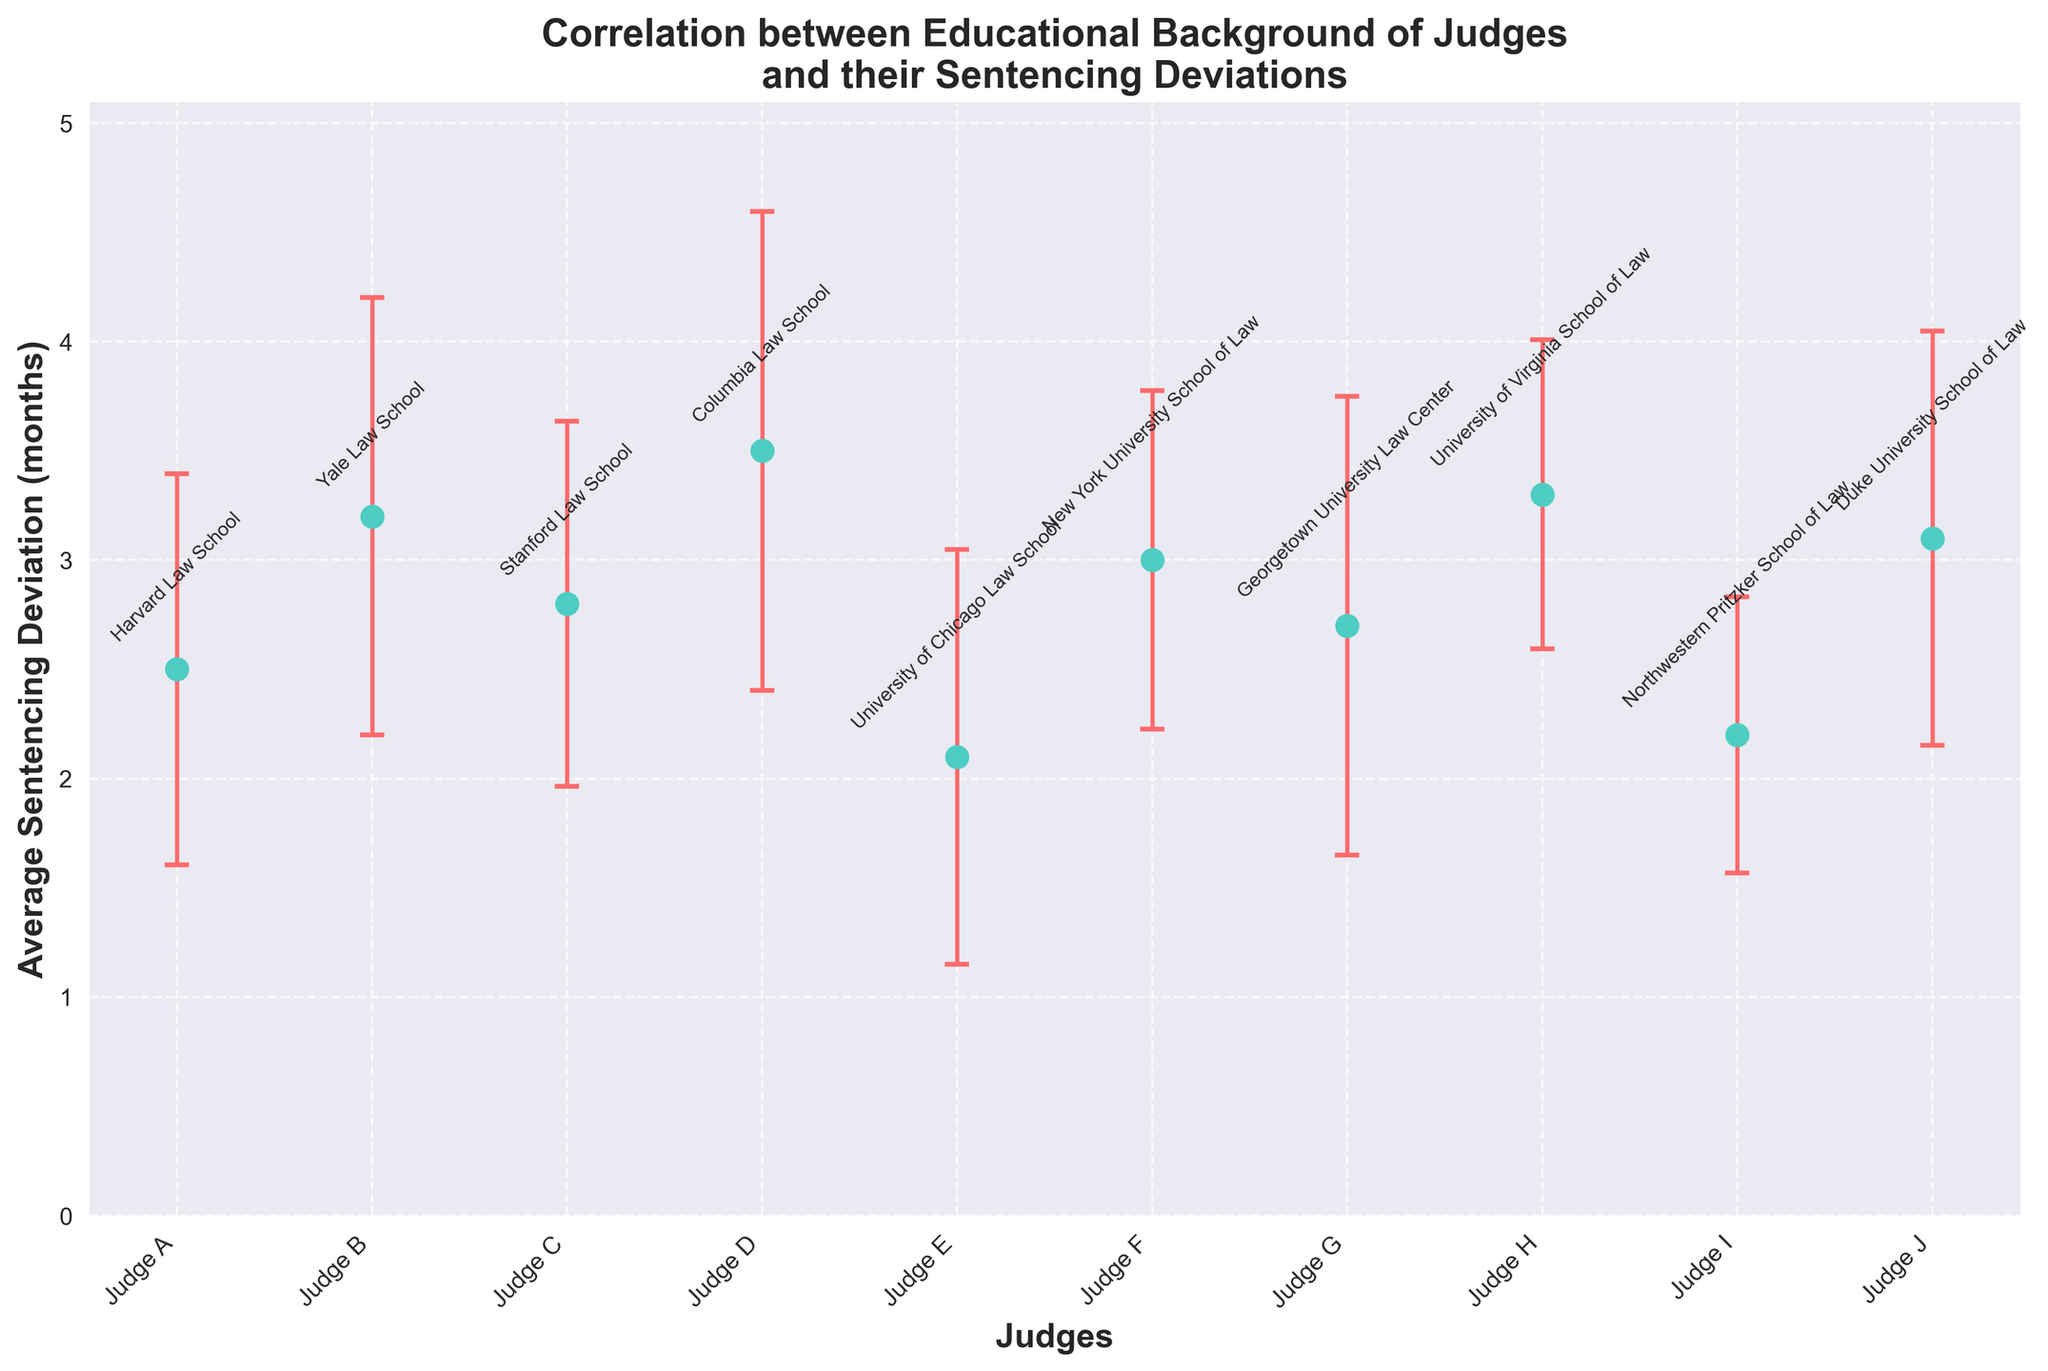What's the title of the figure? The title of the figure is written at the top of the plot, above the data points. It reads "Correlation between Educational Background of Judges and their Sentencing Deviations".
Answer: Correlation between Educational Background of Judges and their Sentencing Deviations How many judges are represented in the figure? The x-axis of the plot represents the judges. Counting the number of distinct data points gives us the total number of judges represented. There are 10 data points.
Answer: 10 Which judge has the highest average sentencing deviation? To find the highest average sentencing deviation, we look for the data point with the maximum y-value. Judge D from Columbia Law School has the highest value at 3.5 months.
Answer: Judge D What is the variance in sentencing deviations for Judge H? The error bars represent the variance, and we can also get this information from the data table. For Judge H from the University of Virginia School of Law, the variance value is 0.5.
Answer: 0.5 What is the approximate range of the average sentencing deviations represented in the figure? To find the range, we identify the lowest and highest y-values. The lowest is 2.1 (Judge E), and the highest is 3.5 (Judge D). Thus, the range is 3.5 - 2.1.
Answer: 1.4 Which two judges have the closest average sentencing deviations? To determine which two judges have the closest deviations, we compare the y-values. Judge C (2.8) and Judge G (2.7) have the closest deviations, with a difference of only 0.1 months.
Answer: Judge C and Judge G Which educational background corresponds to the judge with the smallest variance in sentencing deviations? We look for the smallest error bar or the smallest variance value. The smallest variance, 0.4, is for Judge I, who graduated from Northwestern Pritzker School of Law.
Answer: Northwestern Pritzker School of Law What is the average of the sentencing deviations for all judges? To compute the average, sum all the average sentencing deviations and divide by the number of judges. (2.5 + 3.2 + 2.8 + 3.5 + 2.1 + 3.0 + 2.7 + 3.3 + 2.2 + 3.1) / 10 = 2.94.
Answer: 2.94 Compare the sentencing deviation of Judge A and Judge F. Which one is greater? By how much? Judge A has an average deviation of 2.5 months, while Judge F has 3.0 months. Judge F's deviation is greater. The difference is 3.0 - 2.5 = 0.5 months.
Answer: Judge F, 0.5 months 